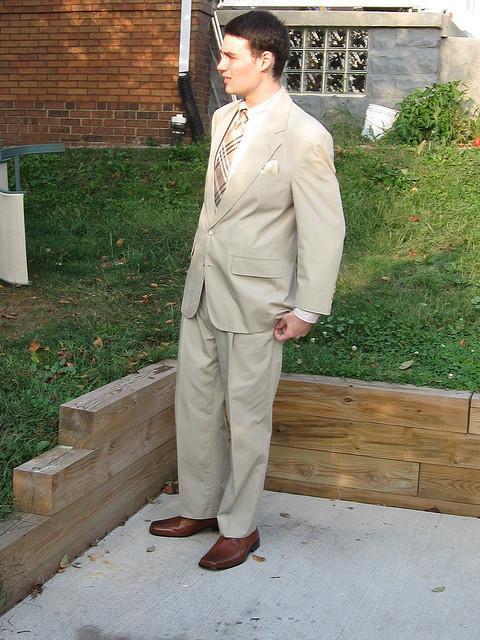How many giraffes are in the photo?
Give a very brief answer. 0. 